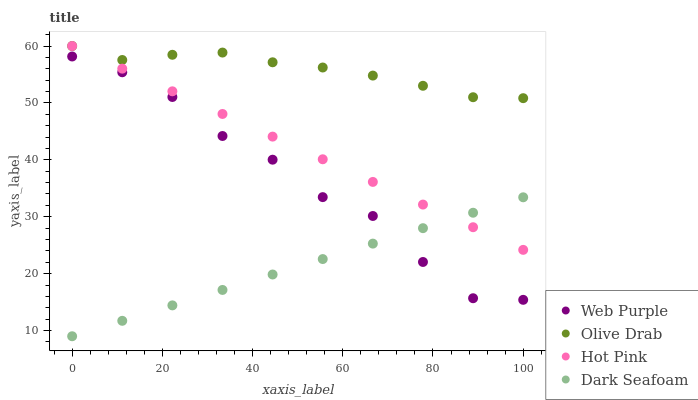Does Dark Seafoam have the minimum area under the curve?
Answer yes or no. Yes. Does Olive Drab have the maximum area under the curve?
Answer yes or no. Yes. Does Hot Pink have the minimum area under the curve?
Answer yes or no. No. Does Hot Pink have the maximum area under the curve?
Answer yes or no. No. Is Dark Seafoam the smoothest?
Answer yes or no. Yes. Is Web Purple the roughest?
Answer yes or no. Yes. Is Hot Pink the smoothest?
Answer yes or no. No. Is Hot Pink the roughest?
Answer yes or no. No. Does Dark Seafoam have the lowest value?
Answer yes or no. Yes. Does Hot Pink have the lowest value?
Answer yes or no. No. Does Olive Drab have the highest value?
Answer yes or no. Yes. Does Dark Seafoam have the highest value?
Answer yes or no. No. Is Web Purple less than Olive Drab?
Answer yes or no. Yes. Is Olive Drab greater than Web Purple?
Answer yes or no. Yes. Does Olive Drab intersect Hot Pink?
Answer yes or no. Yes. Is Olive Drab less than Hot Pink?
Answer yes or no. No. Is Olive Drab greater than Hot Pink?
Answer yes or no. No. Does Web Purple intersect Olive Drab?
Answer yes or no. No. 